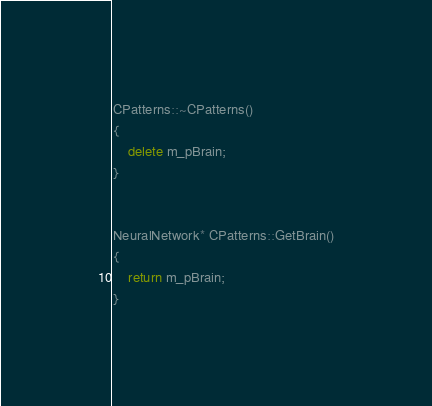<code> <loc_0><loc_0><loc_500><loc_500><_C++_>CPatterns::~CPatterns() 
{
	delete m_pBrain;
}


NeuralNetwork* CPatterns::GetBrain()
{
	return m_pBrain;
}
</code> 